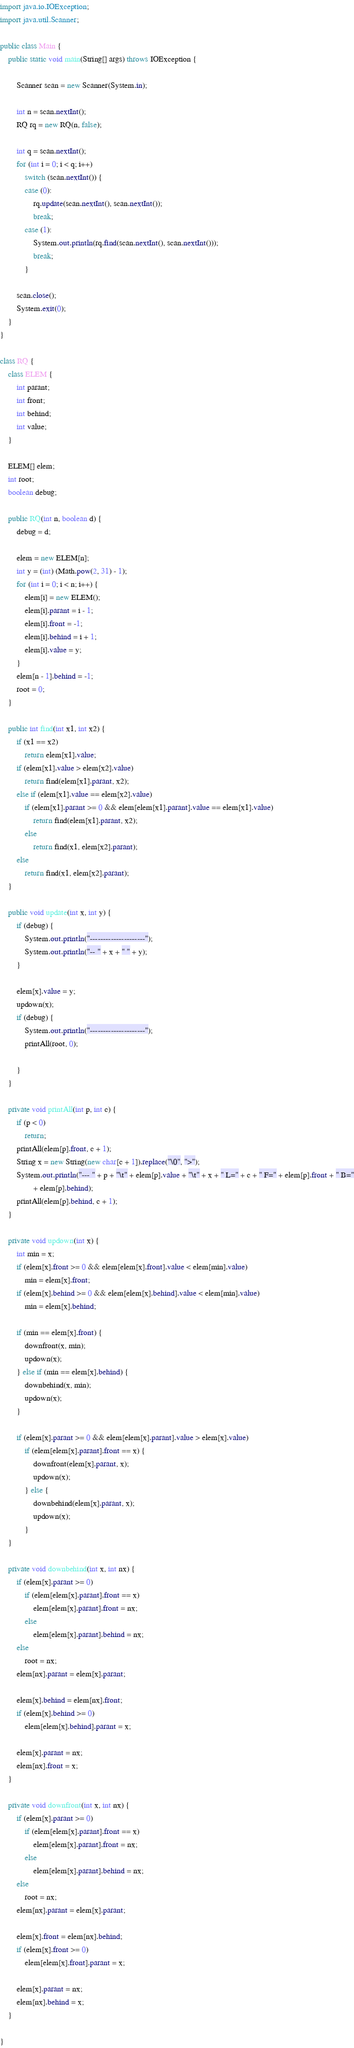<code> <loc_0><loc_0><loc_500><loc_500><_Java_>import java.io.IOException;
import java.util.Scanner;

public class Main {
	public static void main(String[] args) throws IOException {

		Scanner scan = new Scanner(System.in);

		int n = scan.nextInt();
		RQ rq = new RQ(n, false);

		int q = scan.nextInt();
		for (int i = 0; i < q; i++)
			switch (scan.nextInt()) {
			case (0):
				rq.update(scan.nextInt(), scan.nextInt());
				break;
			case (1):
				System.out.println(rq.find(scan.nextInt(), scan.nextInt()));
				break;
			}

		scan.close();
		System.exit(0);
	}
}

class RQ {
	class ELEM {
		int parant;
		int front;
		int behind;
		int value;
	}

	ELEM[] elem;
	int root;
	boolean debug;

	public RQ(int n, boolean d) {
		debug = d;

		elem = new ELEM[n];
		int y = (int) (Math.pow(2, 31) - 1);
		for (int i = 0; i < n; i++) {
			elem[i] = new ELEM();
			elem[i].parant = i - 1;
			elem[i].front = -1;
			elem[i].behind = i + 1;
			elem[i].value = y;
		}
		elem[n - 1].behind = -1;
		root = 0;
	}

	public int find(int x1, int x2) {
		if (x1 == x2)
			return elem[x1].value;
		if (elem[x1].value > elem[x2].value)
			return find(elem[x1].parant, x2);
		else if (elem[x1].value == elem[x2].value)
			if (elem[x1].parant >= 0 && elem[elem[x1].parant].value == elem[x1].value)
				return find(elem[x1].parant, x2);
			else
				return find(x1, elem[x2].parant);
		else
			return find(x1, elem[x2].parant);
	}

	public void update(int x, int y) {
		if (debug) {
			System.out.println("---------------------");
			System.out.println("-- " + x + " " + y);
		}

		elem[x].value = y;
		updown(x);
		if (debug) {
			System.out.println("---------------------");
			printAll(root, 0);

		}
	}

	private void printAll(int p, int c) {
		if (p < 0)
			return;
		printAll(elem[p].front, c + 1);
		String x = new String(new char[c + 1]).replace("\0", ">");
		System.out.println("--- " + p + "\t" + elem[p].value + "\t" + x + " L=" + c + " F=" + elem[p].front + " B="
				+ elem[p].behind);
		printAll(elem[p].behind, c + 1);
	}

	private void updown(int x) {
		int min = x;
		if (elem[x].front >= 0 && elem[elem[x].front].value < elem[min].value)
			min = elem[x].front;
		if (elem[x].behind >= 0 && elem[elem[x].behind].value < elem[min].value)
			min = elem[x].behind;

		if (min == elem[x].front) {
			downfront(x, min);
			updown(x);
		} else if (min == elem[x].behind) {
			downbehind(x, min);
			updown(x);
		}

		if (elem[x].parant >= 0 && elem[elem[x].parant].value > elem[x].value)
			if (elem[elem[x].parant].front == x) {
				downfront(elem[x].parant, x);
				updown(x);
			} else {
				downbehind(elem[x].parant, x);
				updown(x);
			}
	}

	private void downbehind(int x, int nx) {
		if (elem[x].parant >= 0)
			if (elem[elem[x].parant].front == x)
				elem[elem[x].parant].front = nx;
			else
				elem[elem[x].parant].behind = nx;
		else
			root = nx;
		elem[nx].parant = elem[x].parant;

		elem[x].behind = elem[nx].front;
		if (elem[x].behind >= 0)
			elem[elem[x].behind].parant = x;

		elem[x].parant = nx;
		elem[nx].front = x;
	}

	private void downfront(int x, int nx) {
		if (elem[x].parant >= 0)
			if (elem[elem[x].parant].front == x)
				elem[elem[x].parant].front = nx;
			else
				elem[elem[x].parant].behind = nx;
		else
			root = nx;
		elem[nx].parant = elem[x].parant;

		elem[x].front = elem[nx].behind;
		if (elem[x].front >= 0)
			elem[elem[x].front].parant = x;

		elem[x].parant = nx;
		elem[nx].behind = x;
	}

}</code> 